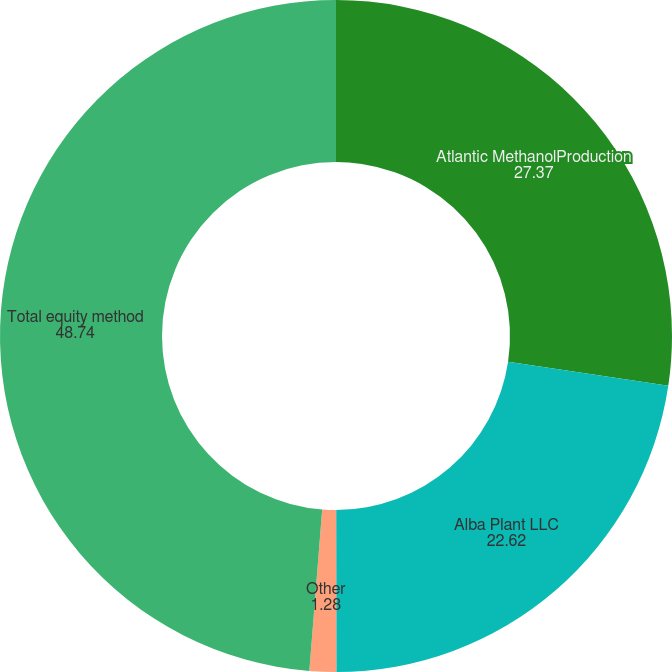<chart> <loc_0><loc_0><loc_500><loc_500><pie_chart><fcel>Atlantic MethanolProduction<fcel>Alba Plant LLC<fcel>Other<fcel>Total equity method<nl><fcel>27.37%<fcel>22.62%<fcel>1.28%<fcel>48.74%<nl></chart> 